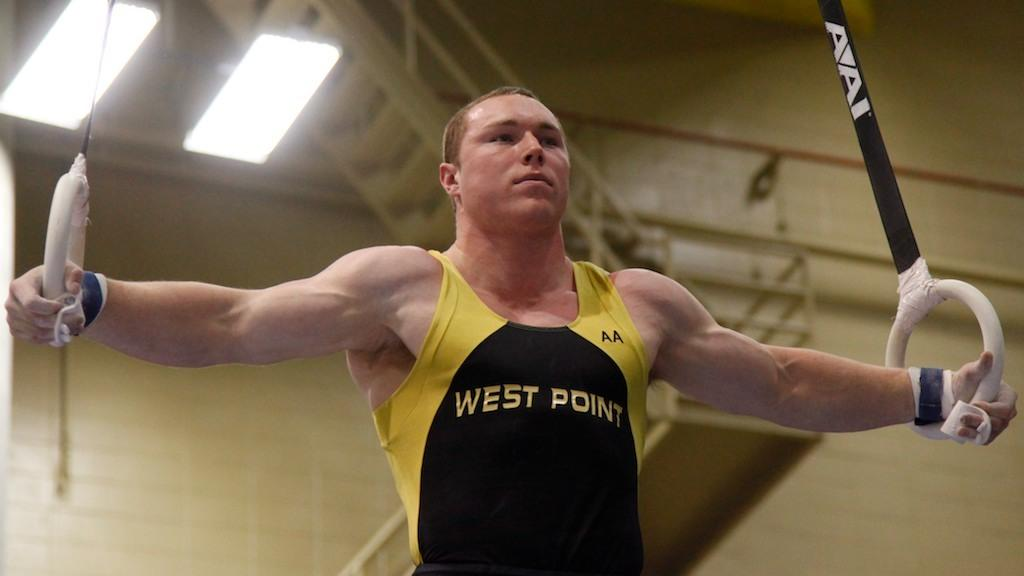Provide a one-sentence caption for the provided image. A gymnast in a West Point uniform in iron cross formation on the rings. 